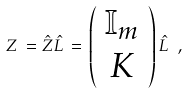<formula> <loc_0><loc_0><loc_500><loc_500>Z \, = \hat { Z } \hat { L } \, = \, \left ( \begin{array} { c } { \mathbb { I } } _ { m } \\ K \end{array} \right ) \hat { L } \ ,</formula> 